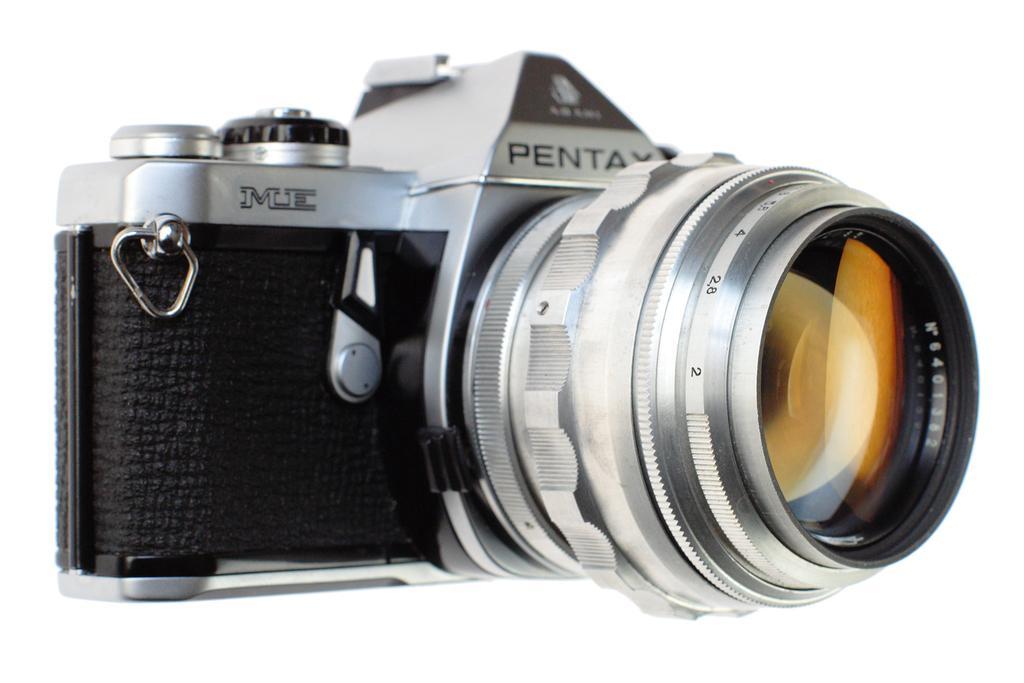How would you summarize this image in a sentence or two? This picture describe about that there is a black and silver camera in the image. 